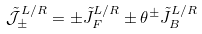<formula> <loc_0><loc_0><loc_500><loc_500>\mathcal { \tilde { J } } _ { \pm } ^ { L / R } & = \pm \tilde { J } _ { F } ^ { L / R } \pm \theta ^ { \pm } \tilde { J } _ { B } ^ { L / R }</formula> 